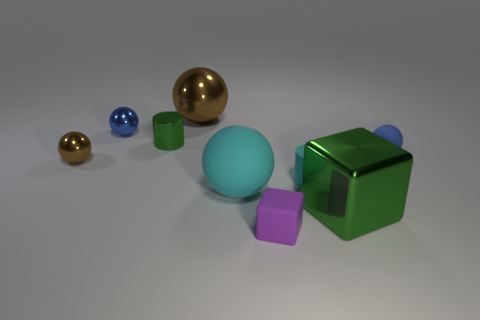Add 1 red cubes. How many objects exist? 10 Subtract all small matte spheres. How many spheres are left? 4 Subtract 1 cylinders. How many cylinders are left? 1 Subtract all brown cylinders. Subtract all purple spheres. How many cylinders are left? 2 Subtract all green cubes. How many blue balls are left? 2 Subtract all small yellow rubber things. Subtract all large cyan rubber balls. How many objects are left? 8 Add 7 metal balls. How many metal balls are left? 10 Add 3 small purple rubber cubes. How many small purple rubber cubes exist? 4 Subtract all purple cubes. How many cubes are left? 1 Subtract 0 purple cylinders. How many objects are left? 9 